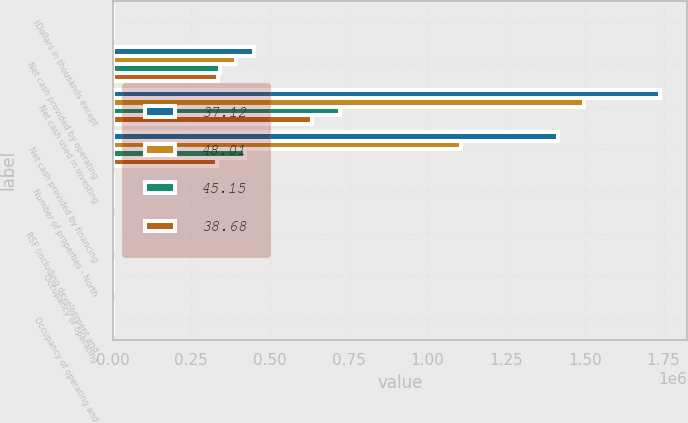Convert chart. <chart><loc_0><loc_0><loc_500><loc_500><stacked_bar_chart><ecel><fcel>(Dollars in thousands except<fcel>Net cash provided by operating<fcel>Net cash used in investing<fcel>Net cash provided by financing<fcel>Number of properties - North<fcel>RSF (including development and<fcel>Occupancy of operating<fcel>Occupancy of operating and<nl><fcel>37.12<fcel>2017<fcel>450325<fcel>1.73813e+06<fcel>1.41543e+06<fcel>213<fcel>2015.5<fcel>96.8<fcel>94.7<nl><fcel>48.01<fcel>2016<fcel>392501<fcel>1.49663e+06<fcel>1.10552e+06<fcel>199<fcel>2015.5<fcel>96.6<fcel>95.7<nl><fcel>45.15<fcel>2015<fcel>342611<fcel>722395<fcel>419126<fcel>191<fcel>2015.5<fcel>97.2<fcel>93.7<nl><fcel>38.68<fcel>2014<fcel>334325<fcel>634829<fcel>331312<fcel>184<fcel>2015.5<fcel>97<fcel>96.1<nl></chart> 